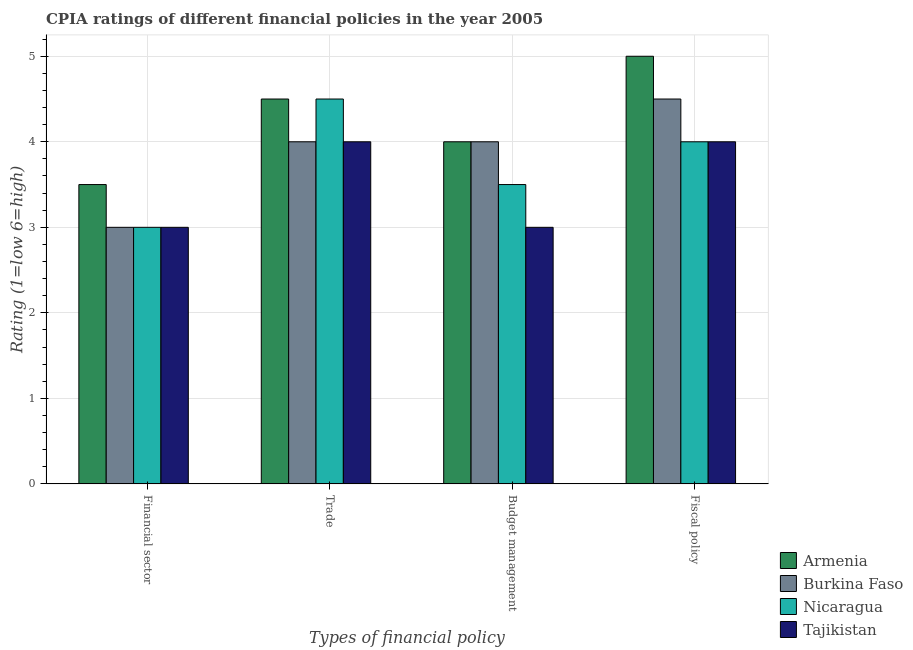Are the number of bars on each tick of the X-axis equal?
Your answer should be very brief. Yes. How many bars are there on the 3rd tick from the left?
Provide a short and direct response. 4. What is the label of the 4th group of bars from the left?
Your answer should be very brief. Fiscal policy. What is the cpia rating of budget management in Burkina Faso?
Your answer should be very brief. 4. Across all countries, what is the maximum cpia rating of fiscal policy?
Your response must be concise. 5. In which country was the cpia rating of fiscal policy maximum?
Your answer should be compact. Armenia. In which country was the cpia rating of trade minimum?
Keep it short and to the point. Burkina Faso. What is the total cpia rating of financial sector in the graph?
Your answer should be very brief. 12.5. What is the average cpia rating of trade per country?
Give a very brief answer. 4.25. What is the difference between the cpia rating of budget management and cpia rating of trade in Armenia?
Provide a succinct answer. -0.5. In how many countries, is the cpia rating of financial sector greater than 3.4 ?
Ensure brevity in your answer.  1. Is the cpia rating of financial sector in Nicaragua less than that in Burkina Faso?
Provide a short and direct response. No. What is the difference between the highest and the lowest cpia rating of trade?
Provide a short and direct response. 0.5. What does the 2nd bar from the left in Fiscal policy represents?
Make the answer very short. Burkina Faso. What does the 3rd bar from the right in Budget management represents?
Your answer should be very brief. Burkina Faso. Is it the case that in every country, the sum of the cpia rating of financial sector and cpia rating of trade is greater than the cpia rating of budget management?
Your answer should be compact. Yes. How many bars are there?
Ensure brevity in your answer.  16. How many countries are there in the graph?
Keep it short and to the point. 4. Does the graph contain any zero values?
Offer a terse response. No. How many legend labels are there?
Give a very brief answer. 4. How are the legend labels stacked?
Keep it short and to the point. Vertical. What is the title of the graph?
Provide a succinct answer. CPIA ratings of different financial policies in the year 2005. What is the label or title of the X-axis?
Keep it short and to the point. Types of financial policy. What is the Rating (1=low 6=high) of Nicaragua in Financial sector?
Keep it short and to the point. 3. What is the Rating (1=low 6=high) in Tajikistan in Financial sector?
Your answer should be very brief. 3. What is the Rating (1=low 6=high) of Armenia in Trade?
Offer a terse response. 4.5. What is the Rating (1=low 6=high) in Tajikistan in Trade?
Make the answer very short. 4. What is the Rating (1=low 6=high) in Armenia in Budget management?
Your answer should be very brief. 4. What is the Rating (1=low 6=high) of Burkina Faso in Budget management?
Provide a succinct answer. 4. What is the Rating (1=low 6=high) in Nicaragua in Budget management?
Keep it short and to the point. 3.5. What is the Rating (1=low 6=high) in Burkina Faso in Fiscal policy?
Keep it short and to the point. 4.5. What is the Rating (1=low 6=high) in Nicaragua in Fiscal policy?
Give a very brief answer. 4. What is the Rating (1=low 6=high) of Tajikistan in Fiscal policy?
Make the answer very short. 4. Across all Types of financial policy, what is the maximum Rating (1=low 6=high) in Burkina Faso?
Keep it short and to the point. 4.5. Across all Types of financial policy, what is the maximum Rating (1=low 6=high) of Nicaragua?
Your answer should be very brief. 4.5. Across all Types of financial policy, what is the minimum Rating (1=low 6=high) in Tajikistan?
Provide a succinct answer. 3. What is the total Rating (1=low 6=high) in Armenia in the graph?
Offer a very short reply. 17. What is the total Rating (1=low 6=high) of Tajikistan in the graph?
Your answer should be very brief. 14. What is the difference between the Rating (1=low 6=high) of Armenia in Financial sector and that in Trade?
Your answer should be very brief. -1. What is the difference between the Rating (1=low 6=high) in Burkina Faso in Financial sector and that in Trade?
Make the answer very short. -1. What is the difference between the Rating (1=low 6=high) in Armenia in Financial sector and that in Budget management?
Your answer should be very brief. -0.5. What is the difference between the Rating (1=low 6=high) of Burkina Faso in Financial sector and that in Budget management?
Provide a succinct answer. -1. What is the difference between the Rating (1=low 6=high) of Nicaragua in Financial sector and that in Budget management?
Offer a terse response. -0.5. What is the difference between the Rating (1=low 6=high) in Tajikistan in Financial sector and that in Budget management?
Give a very brief answer. 0. What is the difference between the Rating (1=low 6=high) in Tajikistan in Financial sector and that in Fiscal policy?
Keep it short and to the point. -1. What is the difference between the Rating (1=low 6=high) of Burkina Faso in Trade and that in Budget management?
Offer a terse response. 0. What is the difference between the Rating (1=low 6=high) of Nicaragua in Trade and that in Budget management?
Keep it short and to the point. 1. What is the difference between the Rating (1=low 6=high) in Burkina Faso in Trade and that in Fiscal policy?
Your response must be concise. -0.5. What is the difference between the Rating (1=low 6=high) of Nicaragua in Trade and that in Fiscal policy?
Provide a short and direct response. 0.5. What is the difference between the Rating (1=low 6=high) in Burkina Faso in Budget management and that in Fiscal policy?
Offer a very short reply. -0.5. What is the difference between the Rating (1=low 6=high) of Nicaragua in Budget management and that in Fiscal policy?
Your answer should be compact. -0.5. What is the difference between the Rating (1=low 6=high) in Armenia in Financial sector and the Rating (1=low 6=high) in Tajikistan in Trade?
Give a very brief answer. -0.5. What is the difference between the Rating (1=low 6=high) in Burkina Faso in Financial sector and the Rating (1=low 6=high) in Nicaragua in Trade?
Your answer should be compact. -1.5. What is the difference between the Rating (1=low 6=high) in Nicaragua in Financial sector and the Rating (1=low 6=high) in Tajikistan in Trade?
Your answer should be compact. -1. What is the difference between the Rating (1=low 6=high) in Armenia in Financial sector and the Rating (1=low 6=high) in Nicaragua in Budget management?
Give a very brief answer. 0. What is the difference between the Rating (1=low 6=high) in Burkina Faso in Financial sector and the Rating (1=low 6=high) in Nicaragua in Budget management?
Your answer should be very brief. -0.5. What is the difference between the Rating (1=low 6=high) in Burkina Faso in Financial sector and the Rating (1=low 6=high) in Tajikistan in Budget management?
Provide a succinct answer. 0. What is the difference between the Rating (1=low 6=high) in Nicaragua in Financial sector and the Rating (1=low 6=high) in Tajikistan in Budget management?
Offer a very short reply. 0. What is the difference between the Rating (1=low 6=high) of Armenia in Financial sector and the Rating (1=low 6=high) of Burkina Faso in Fiscal policy?
Make the answer very short. -1. What is the difference between the Rating (1=low 6=high) in Armenia in Financial sector and the Rating (1=low 6=high) in Nicaragua in Fiscal policy?
Provide a succinct answer. -0.5. What is the difference between the Rating (1=low 6=high) in Armenia in Financial sector and the Rating (1=low 6=high) in Tajikistan in Fiscal policy?
Offer a terse response. -0.5. What is the difference between the Rating (1=low 6=high) of Burkina Faso in Financial sector and the Rating (1=low 6=high) of Tajikistan in Fiscal policy?
Your answer should be compact. -1. What is the difference between the Rating (1=low 6=high) of Nicaragua in Financial sector and the Rating (1=low 6=high) of Tajikistan in Fiscal policy?
Make the answer very short. -1. What is the difference between the Rating (1=low 6=high) in Armenia in Trade and the Rating (1=low 6=high) in Tajikistan in Budget management?
Your response must be concise. 1.5. What is the difference between the Rating (1=low 6=high) of Burkina Faso in Trade and the Rating (1=low 6=high) of Tajikistan in Budget management?
Give a very brief answer. 1. What is the difference between the Rating (1=low 6=high) in Nicaragua in Trade and the Rating (1=low 6=high) in Tajikistan in Budget management?
Give a very brief answer. 1.5. What is the difference between the Rating (1=low 6=high) of Armenia in Trade and the Rating (1=low 6=high) of Burkina Faso in Fiscal policy?
Provide a succinct answer. 0. What is the difference between the Rating (1=low 6=high) in Armenia in Trade and the Rating (1=low 6=high) in Tajikistan in Fiscal policy?
Make the answer very short. 0.5. What is the difference between the Rating (1=low 6=high) in Burkina Faso in Trade and the Rating (1=low 6=high) in Nicaragua in Fiscal policy?
Ensure brevity in your answer.  0. What is the difference between the Rating (1=low 6=high) in Burkina Faso in Trade and the Rating (1=low 6=high) in Tajikistan in Fiscal policy?
Ensure brevity in your answer.  0. What is the difference between the Rating (1=low 6=high) in Armenia in Budget management and the Rating (1=low 6=high) in Tajikistan in Fiscal policy?
Give a very brief answer. 0. What is the difference between the Rating (1=low 6=high) in Nicaragua in Budget management and the Rating (1=low 6=high) in Tajikistan in Fiscal policy?
Ensure brevity in your answer.  -0.5. What is the average Rating (1=low 6=high) of Armenia per Types of financial policy?
Your answer should be very brief. 4.25. What is the average Rating (1=low 6=high) of Burkina Faso per Types of financial policy?
Ensure brevity in your answer.  3.88. What is the average Rating (1=low 6=high) in Nicaragua per Types of financial policy?
Keep it short and to the point. 3.75. What is the difference between the Rating (1=low 6=high) in Armenia and Rating (1=low 6=high) in Tajikistan in Financial sector?
Give a very brief answer. 0.5. What is the difference between the Rating (1=low 6=high) of Burkina Faso and Rating (1=low 6=high) of Tajikistan in Financial sector?
Your answer should be compact. 0. What is the difference between the Rating (1=low 6=high) of Nicaragua and Rating (1=low 6=high) of Tajikistan in Financial sector?
Keep it short and to the point. 0. What is the difference between the Rating (1=low 6=high) of Armenia and Rating (1=low 6=high) of Burkina Faso in Trade?
Your answer should be compact. 0.5. What is the difference between the Rating (1=low 6=high) in Armenia and Rating (1=low 6=high) in Nicaragua in Trade?
Keep it short and to the point. 0. What is the difference between the Rating (1=low 6=high) in Burkina Faso and Rating (1=low 6=high) in Nicaragua in Trade?
Provide a short and direct response. -0.5. What is the difference between the Rating (1=low 6=high) in Burkina Faso and Rating (1=low 6=high) in Tajikistan in Trade?
Keep it short and to the point. 0. What is the difference between the Rating (1=low 6=high) of Armenia and Rating (1=low 6=high) of Burkina Faso in Budget management?
Your answer should be very brief. 0. What is the difference between the Rating (1=low 6=high) of Burkina Faso and Rating (1=low 6=high) of Nicaragua in Budget management?
Offer a very short reply. 0.5. What is the difference between the Rating (1=low 6=high) of Nicaragua and Rating (1=low 6=high) of Tajikistan in Budget management?
Offer a terse response. 0.5. What is the difference between the Rating (1=low 6=high) in Armenia and Rating (1=low 6=high) in Tajikistan in Fiscal policy?
Offer a very short reply. 1. What is the difference between the Rating (1=low 6=high) in Burkina Faso and Rating (1=low 6=high) in Nicaragua in Fiscal policy?
Provide a short and direct response. 0.5. What is the difference between the Rating (1=low 6=high) in Burkina Faso and Rating (1=low 6=high) in Tajikistan in Fiscal policy?
Make the answer very short. 0.5. What is the difference between the Rating (1=low 6=high) in Nicaragua and Rating (1=low 6=high) in Tajikistan in Fiscal policy?
Your answer should be compact. 0. What is the ratio of the Rating (1=low 6=high) in Armenia in Financial sector to that in Trade?
Make the answer very short. 0.78. What is the ratio of the Rating (1=low 6=high) in Burkina Faso in Financial sector to that in Trade?
Provide a succinct answer. 0.75. What is the ratio of the Rating (1=low 6=high) of Nicaragua in Financial sector to that in Trade?
Make the answer very short. 0.67. What is the ratio of the Rating (1=low 6=high) in Burkina Faso in Financial sector to that in Budget management?
Make the answer very short. 0.75. What is the ratio of the Rating (1=low 6=high) of Nicaragua in Financial sector to that in Budget management?
Your response must be concise. 0.86. What is the ratio of the Rating (1=low 6=high) of Burkina Faso in Financial sector to that in Fiscal policy?
Keep it short and to the point. 0.67. What is the ratio of the Rating (1=low 6=high) of Burkina Faso in Trade to that in Budget management?
Your answer should be compact. 1. What is the ratio of the Rating (1=low 6=high) of Tajikistan in Trade to that in Budget management?
Offer a terse response. 1.33. What is the ratio of the Rating (1=low 6=high) of Burkina Faso in Trade to that in Fiscal policy?
Offer a very short reply. 0.89. What is the ratio of the Rating (1=low 6=high) of Nicaragua in Trade to that in Fiscal policy?
Offer a very short reply. 1.12. What is the ratio of the Rating (1=low 6=high) in Tajikistan in Trade to that in Fiscal policy?
Provide a succinct answer. 1. What is the ratio of the Rating (1=low 6=high) of Armenia in Budget management to that in Fiscal policy?
Your response must be concise. 0.8. What is the ratio of the Rating (1=low 6=high) in Nicaragua in Budget management to that in Fiscal policy?
Provide a short and direct response. 0.88. What is the ratio of the Rating (1=low 6=high) in Tajikistan in Budget management to that in Fiscal policy?
Your answer should be very brief. 0.75. What is the difference between the highest and the second highest Rating (1=low 6=high) of Armenia?
Offer a very short reply. 0.5. What is the difference between the highest and the lowest Rating (1=low 6=high) in Nicaragua?
Offer a very short reply. 1.5. 